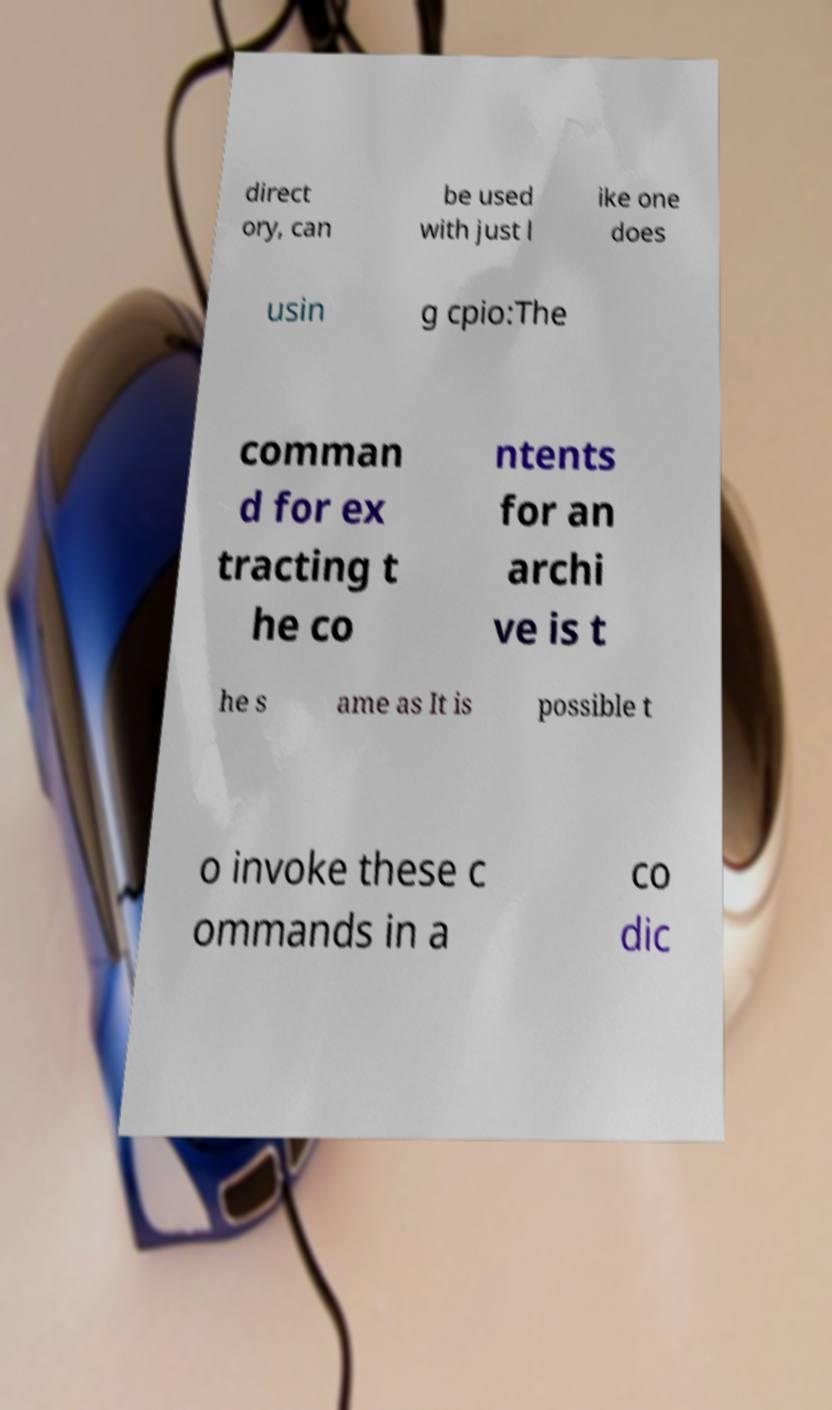Please identify and transcribe the text found in this image. direct ory, can be used with just l ike one does usin g cpio:The comman d for ex tracting t he co ntents for an archi ve is t he s ame as It is possible t o invoke these c ommands in a co dic 